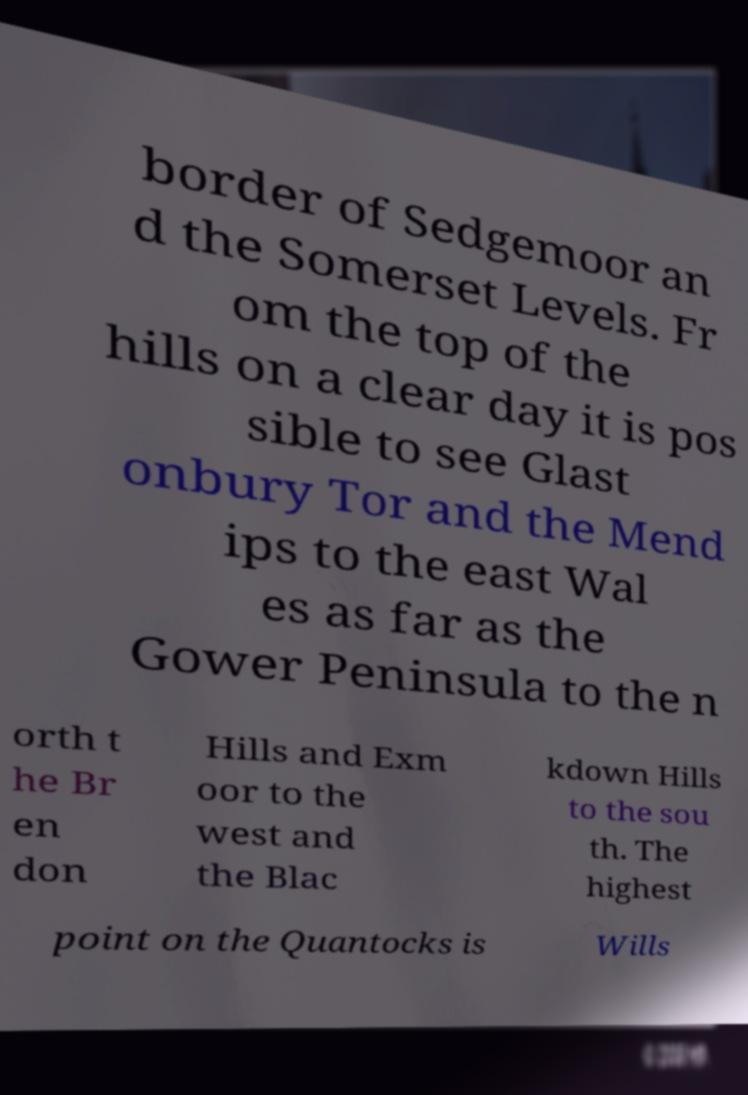For documentation purposes, I need the text within this image transcribed. Could you provide that? border of Sedgemoor an d the Somerset Levels. Fr om the top of the hills on a clear day it is pos sible to see Glast onbury Tor and the Mend ips to the east Wal es as far as the Gower Peninsula to the n orth t he Br en don Hills and Exm oor to the west and the Blac kdown Hills to the sou th. The highest point on the Quantocks is Wills 